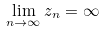<formula> <loc_0><loc_0><loc_500><loc_500>\lim _ { n \rightarrow \infty } z _ { n } = \infty</formula> 